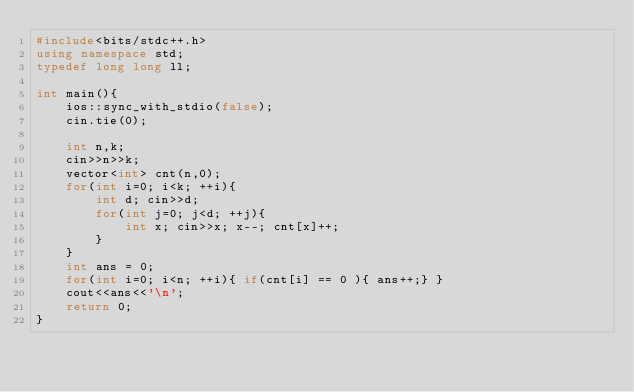<code> <loc_0><loc_0><loc_500><loc_500><_C++_>#include<bits/stdc++.h>
using namespace std;
typedef long long ll;

int main(){
	ios::sync_with_stdio(false);
	cin.tie(0);

	int n,k;
	cin>>n>>k;
	vector<int> cnt(n,0);
	for(int i=0; i<k; ++i){
		int d; cin>>d;
		for(int j=0; j<d; ++j){
			int x; cin>>x; x--; cnt[x]++;
		}
	}
	int ans = 0;
	for(int i=0; i<n; ++i){ if(cnt[i] == 0 ){ ans++;} }
	cout<<ans<<'\n';
	return 0;
}
</code> 